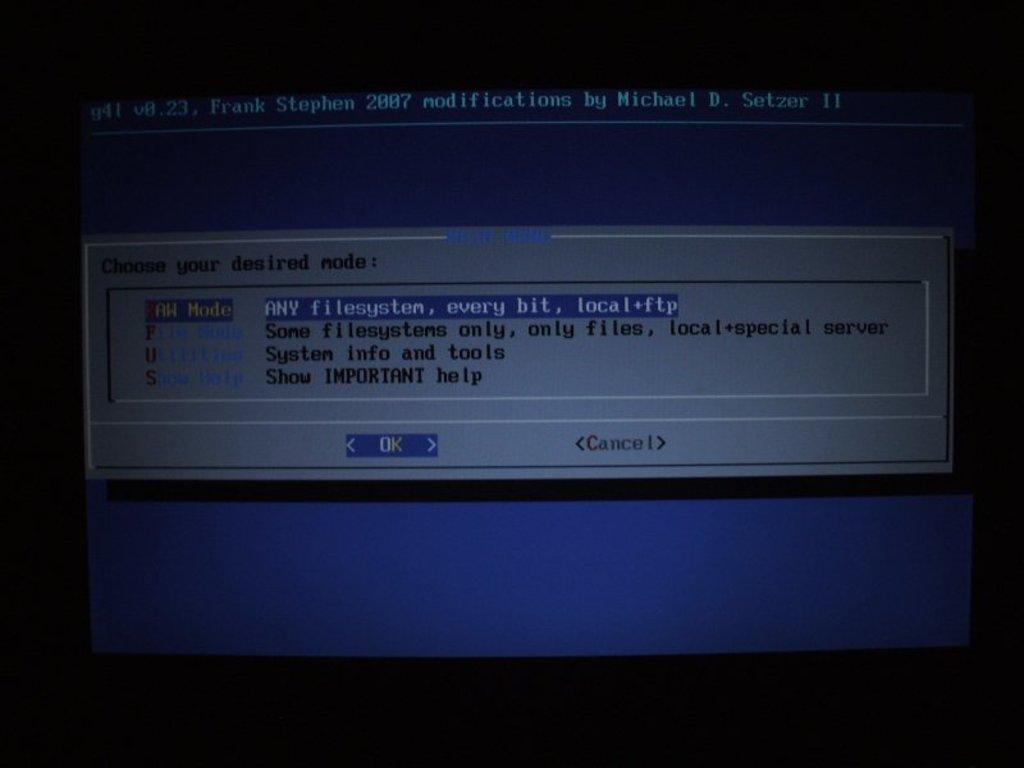What year is this program?
Provide a succinct answer. 2007. 